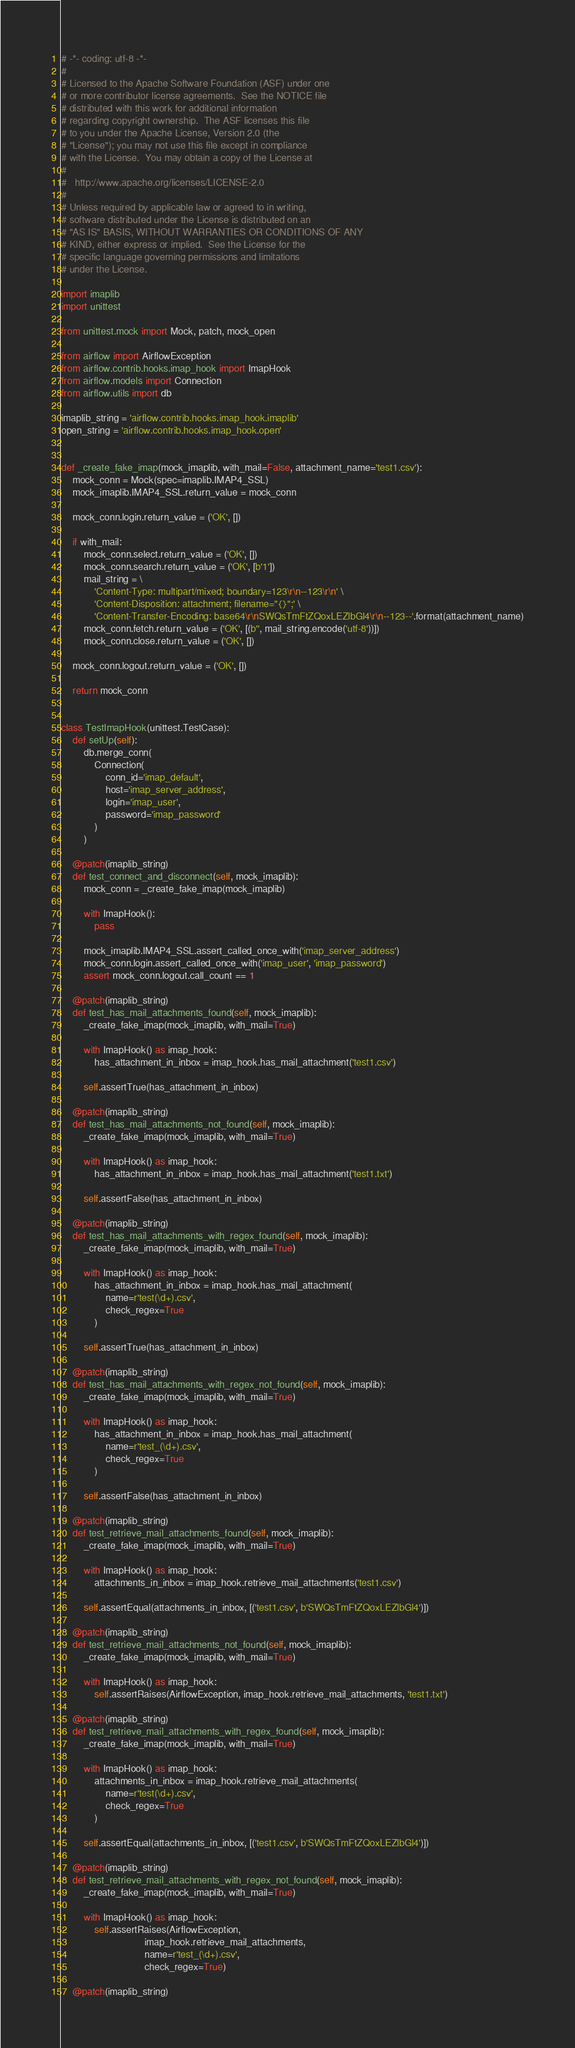Convert code to text. <code><loc_0><loc_0><loc_500><loc_500><_Python_># -*- coding: utf-8 -*-
#
# Licensed to the Apache Software Foundation (ASF) under one
# or more contributor license agreements.  See the NOTICE file
# distributed with this work for additional information
# regarding copyright ownership.  The ASF licenses this file
# to you under the Apache License, Version 2.0 (the
# "License"); you may not use this file except in compliance
# with the License.  You may obtain a copy of the License at
#
#   http://www.apache.org/licenses/LICENSE-2.0
#
# Unless required by applicable law or agreed to in writing,
# software distributed under the License is distributed on an
# "AS IS" BASIS, WITHOUT WARRANTIES OR CONDITIONS OF ANY
# KIND, either express or implied.  See the License for the
# specific language governing permissions and limitations
# under the License.

import imaplib
import unittest

from unittest.mock import Mock, patch, mock_open

from airflow import AirflowException
from airflow.contrib.hooks.imap_hook import ImapHook
from airflow.models import Connection
from airflow.utils import db

imaplib_string = 'airflow.contrib.hooks.imap_hook.imaplib'
open_string = 'airflow.contrib.hooks.imap_hook.open'


def _create_fake_imap(mock_imaplib, with_mail=False, attachment_name='test1.csv'):
    mock_conn = Mock(spec=imaplib.IMAP4_SSL)
    mock_imaplib.IMAP4_SSL.return_value = mock_conn

    mock_conn.login.return_value = ('OK', [])

    if with_mail:
        mock_conn.select.return_value = ('OK', [])
        mock_conn.search.return_value = ('OK', [b'1'])
        mail_string = \
            'Content-Type: multipart/mixed; boundary=123\r\n--123\r\n' \
            'Content-Disposition: attachment; filename="{}";' \
            'Content-Transfer-Encoding: base64\r\nSWQsTmFtZQoxLEZlbGl4\r\n--123--'.format(attachment_name)
        mock_conn.fetch.return_value = ('OK', [(b'', mail_string.encode('utf-8'))])
        mock_conn.close.return_value = ('OK', [])

    mock_conn.logout.return_value = ('OK', [])

    return mock_conn


class TestImapHook(unittest.TestCase):
    def setUp(self):
        db.merge_conn(
            Connection(
                conn_id='imap_default',
                host='imap_server_address',
                login='imap_user',
                password='imap_password'
            )
        )

    @patch(imaplib_string)
    def test_connect_and_disconnect(self, mock_imaplib):
        mock_conn = _create_fake_imap(mock_imaplib)

        with ImapHook():
            pass

        mock_imaplib.IMAP4_SSL.assert_called_once_with('imap_server_address')
        mock_conn.login.assert_called_once_with('imap_user', 'imap_password')
        assert mock_conn.logout.call_count == 1

    @patch(imaplib_string)
    def test_has_mail_attachments_found(self, mock_imaplib):
        _create_fake_imap(mock_imaplib, with_mail=True)

        with ImapHook() as imap_hook:
            has_attachment_in_inbox = imap_hook.has_mail_attachment('test1.csv')

        self.assertTrue(has_attachment_in_inbox)

    @patch(imaplib_string)
    def test_has_mail_attachments_not_found(self, mock_imaplib):
        _create_fake_imap(mock_imaplib, with_mail=True)

        with ImapHook() as imap_hook:
            has_attachment_in_inbox = imap_hook.has_mail_attachment('test1.txt')

        self.assertFalse(has_attachment_in_inbox)

    @patch(imaplib_string)
    def test_has_mail_attachments_with_regex_found(self, mock_imaplib):
        _create_fake_imap(mock_imaplib, with_mail=True)

        with ImapHook() as imap_hook:
            has_attachment_in_inbox = imap_hook.has_mail_attachment(
                name=r'test(\d+).csv',
                check_regex=True
            )

        self.assertTrue(has_attachment_in_inbox)

    @patch(imaplib_string)
    def test_has_mail_attachments_with_regex_not_found(self, mock_imaplib):
        _create_fake_imap(mock_imaplib, with_mail=True)

        with ImapHook() as imap_hook:
            has_attachment_in_inbox = imap_hook.has_mail_attachment(
                name=r'test_(\d+).csv',
                check_regex=True
            )

        self.assertFalse(has_attachment_in_inbox)

    @patch(imaplib_string)
    def test_retrieve_mail_attachments_found(self, mock_imaplib):
        _create_fake_imap(mock_imaplib, with_mail=True)

        with ImapHook() as imap_hook:
            attachments_in_inbox = imap_hook.retrieve_mail_attachments('test1.csv')

        self.assertEqual(attachments_in_inbox, [('test1.csv', b'SWQsTmFtZQoxLEZlbGl4')])

    @patch(imaplib_string)
    def test_retrieve_mail_attachments_not_found(self, mock_imaplib):
        _create_fake_imap(mock_imaplib, with_mail=True)

        with ImapHook() as imap_hook:
            self.assertRaises(AirflowException, imap_hook.retrieve_mail_attachments, 'test1.txt')

    @patch(imaplib_string)
    def test_retrieve_mail_attachments_with_regex_found(self, mock_imaplib):
        _create_fake_imap(mock_imaplib, with_mail=True)

        with ImapHook() as imap_hook:
            attachments_in_inbox = imap_hook.retrieve_mail_attachments(
                name=r'test(\d+).csv',
                check_regex=True
            )

        self.assertEqual(attachments_in_inbox, [('test1.csv', b'SWQsTmFtZQoxLEZlbGl4')])

    @patch(imaplib_string)
    def test_retrieve_mail_attachments_with_regex_not_found(self, mock_imaplib):
        _create_fake_imap(mock_imaplib, with_mail=True)

        with ImapHook() as imap_hook:
            self.assertRaises(AirflowException,
                              imap_hook.retrieve_mail_attachments,
                              name=r'test_(\d+).csv',
                              check_regex=True)

    @patch(imaplib_string)</code> 